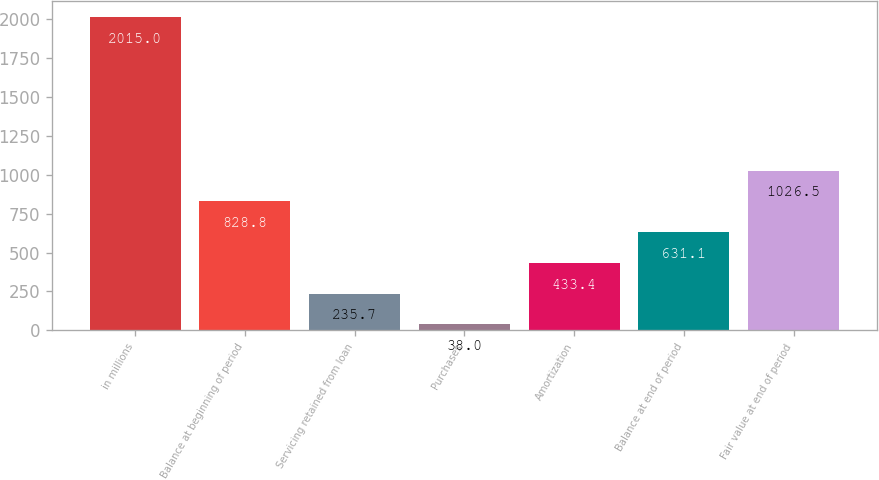Convert chart. <chart><loc_0><loc_0><loc_500><loc_500><bar_chart><fcel>in millions<fcel>Balance at beginning of period<fcel>Servicing retained from loan<fcel>Purchases<fcel>Amortization<fcel>Balance at end of period<fcel>Fair value at end of period<nl><fcel>2015<fcel>828.8<fcel>235.7<fcel>38<fcel>433.4<fcel>631.1<fcel>1026.5<nl></chart> 